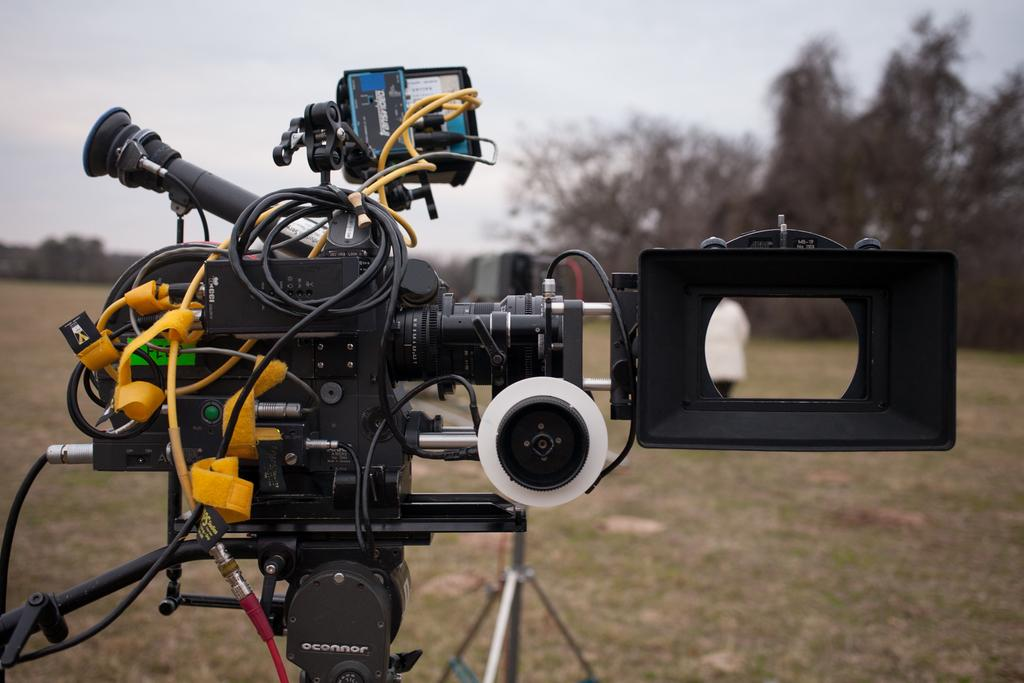What object is located on the left side of the image? There is a video camera holder on the left side of the image. What can be seen in the background of the image? There are trees in the background of the image. Can you see any ghosts in the image? There are no ghosts present in the image. What type of error is visible in the image? There is no error present in the image. 